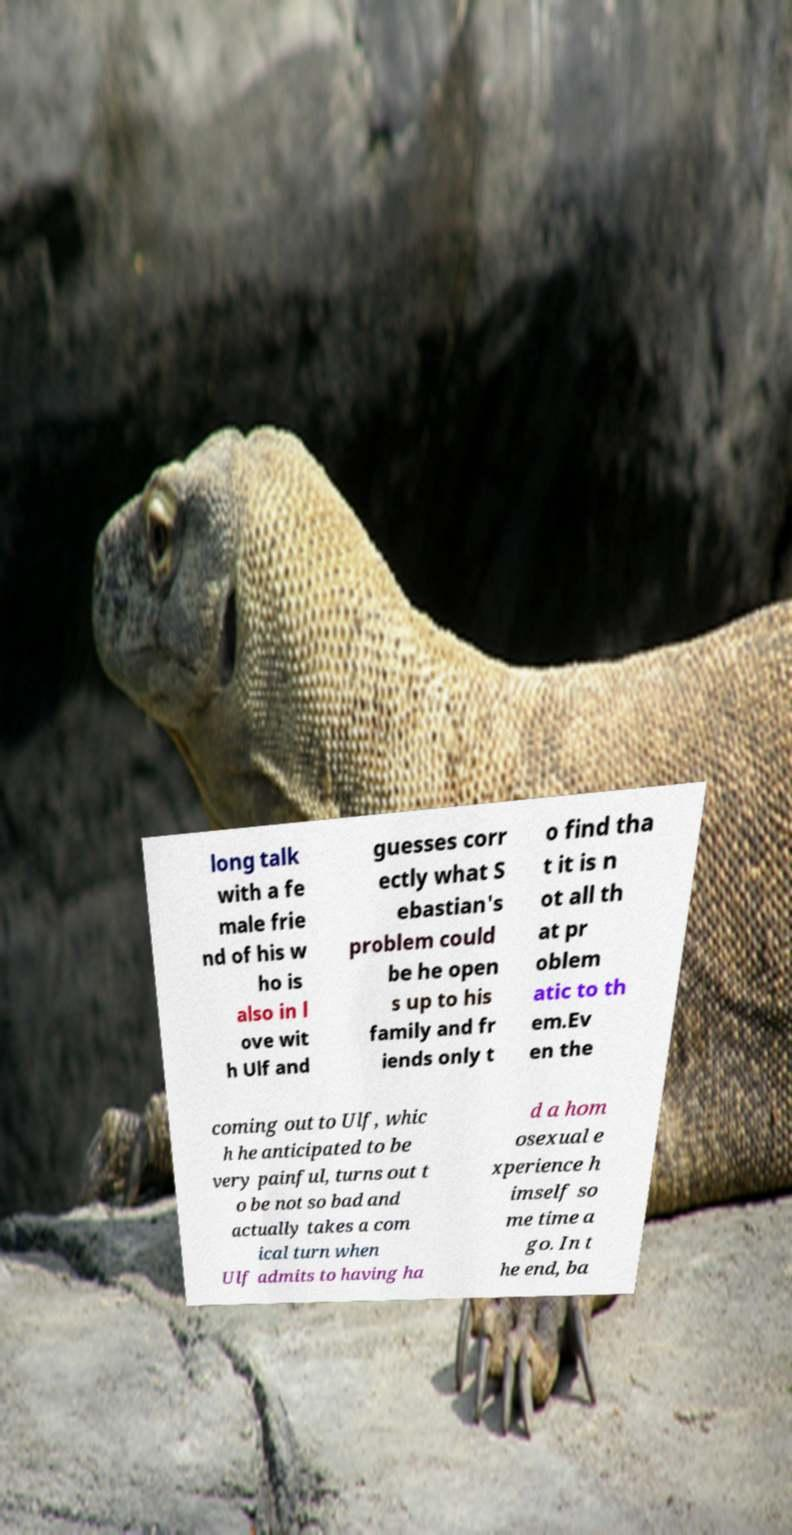Could you assist in decoding the text presented in this image and type it out clearly? long talk with a fe male frie nd of his w ho is also in l ove wit h Ulf and guesses corr ectly what S ebastian's problem could be he open s up to his family and fr iends only t o find tha t it is n ot all th at pr oblem atic to th em.Ev en the coming out to Ulf, whic h he anticipated to be very painful, turns out t o be not so bad and actually takes a com ical turn when Ulf admits to having ha d a hom osexual e xperience h imself so me time a go. In t he end, ba 